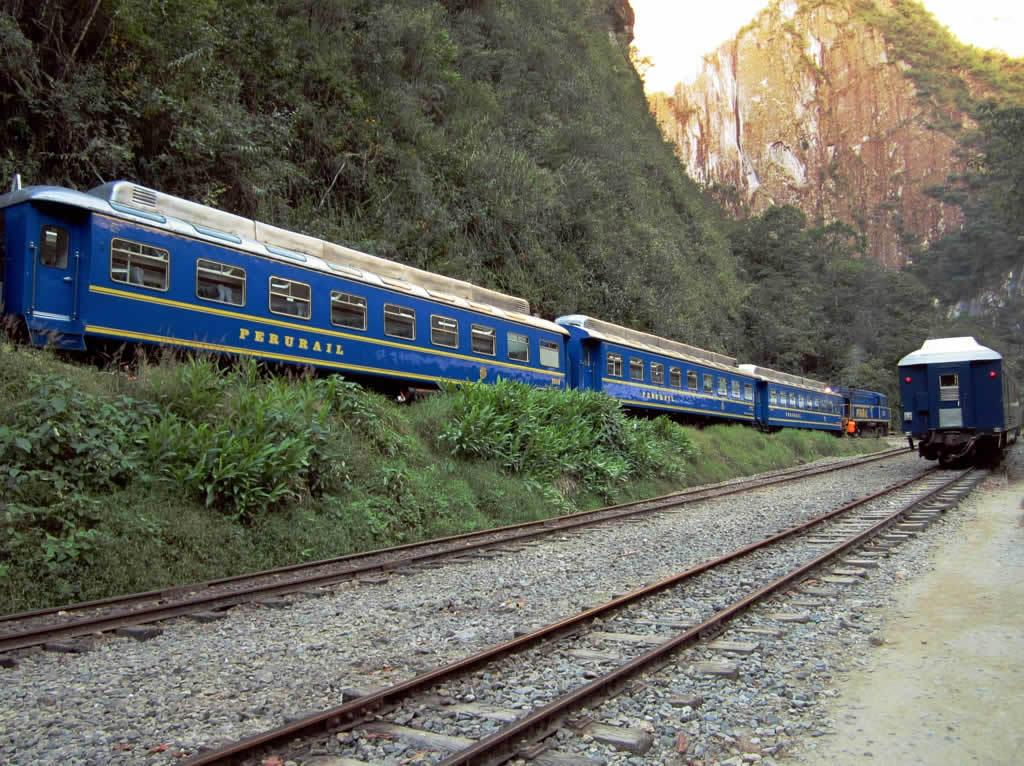What type of vehicles can be seen on the track in the image? There are trains on the track in the image. What type of natural elements are visible in the image? There are stones, plants, hills, and trees visible in the image. Can you describe the background of the image? The background of the image includes hills and trees. What type of jewel is the goat wearing around its neck in the image? There is no goat or jewel present in the image. What type of boundary can be seen separating the hills in the image? There is no boundary visible in the image; only hills and trees are present in the background. 